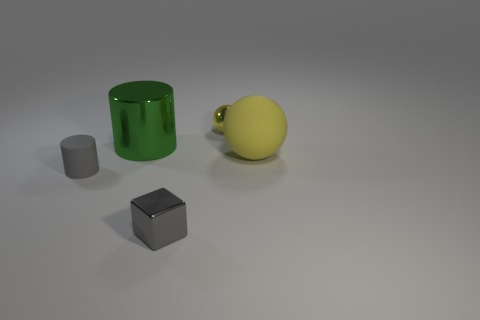Subtract all green cylinders. How many cylinders are left? 1 Add 2 purple metal cylinders. How many objects exist? 7 Subtract all gray blocks. How many brown cylinders are left? 0 Subtract all balls. How many objects are left? 3 Subtract 1 cylinders. How many cylinders are left? 1 Subtract all green blocks. Subtract all brown cylinders. How many blocks are left? 1 Subtract all gray matte things. Subtract all metallic spheres. How many objects are left? 3 Add 1 big balls. How many big balls are left? 2 Add 4 large yellow things. How many large yellow things exist? 5 Subtract 0 red cubes. How many objects are left? 5 